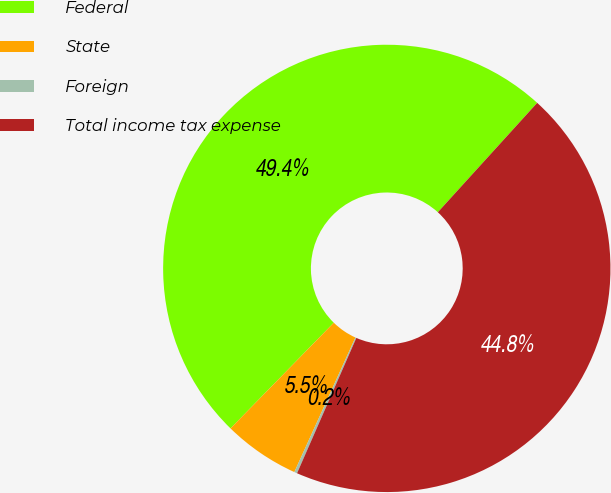Convert chart to OTSL. <chart><loc_0><loc_0><loc_500><loc_500><pie_chart><fcel>Federal<fcel>State<fcel>Foreign<fcel>Total income tax expense<nl><fcel>49.43%<fcel>5.53%<fcel>0.21%<fcel>44.84%<nl></chart> 